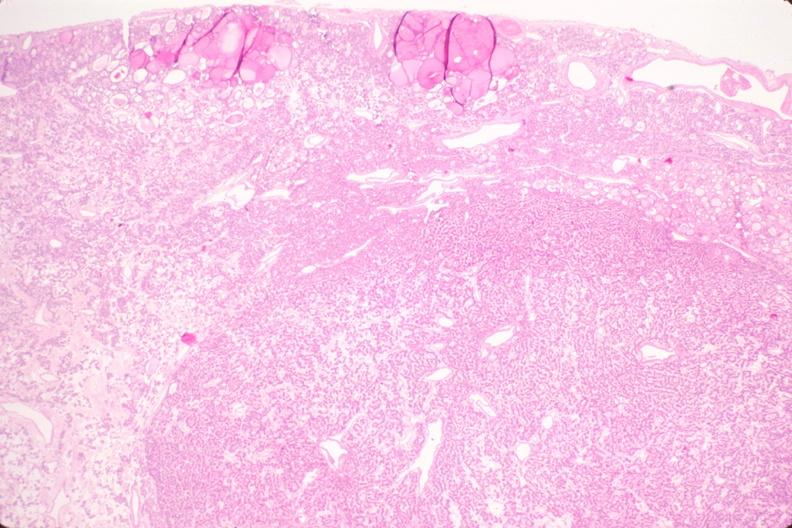where is this part in the figure?
Answer the question using a single word or phrase. Endocrine system 